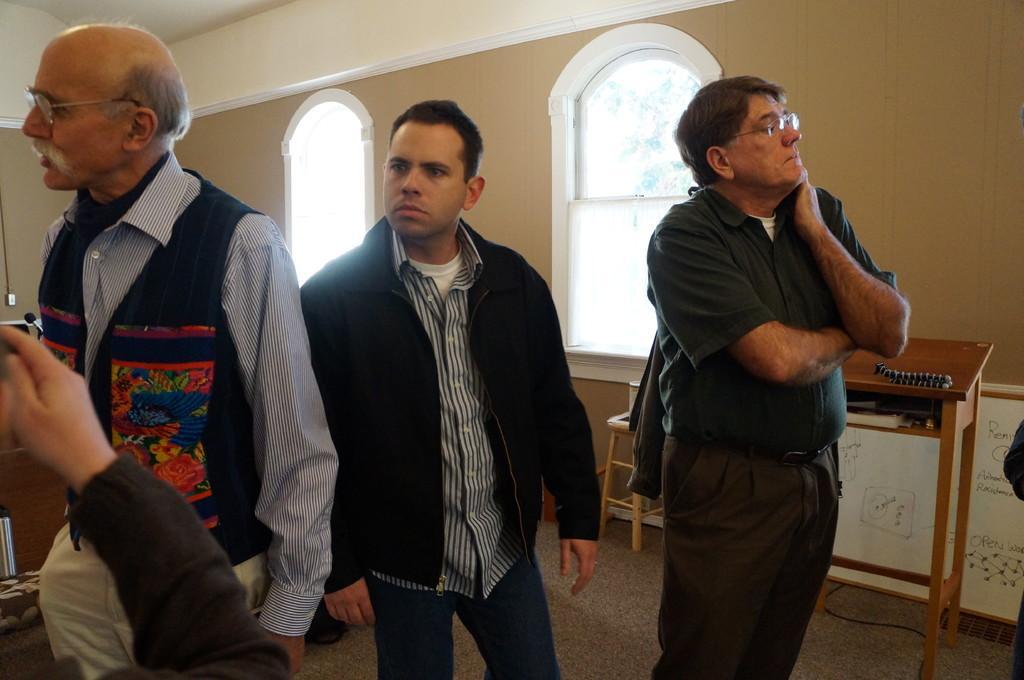In one or two sentences, can you explain what this image depicts? In this image we can see few persons are standing on the floor. In the background we can see windows, wall, objects on the stool and table, texts written on a boar and on the right side we can see a person's hand and other objects. 